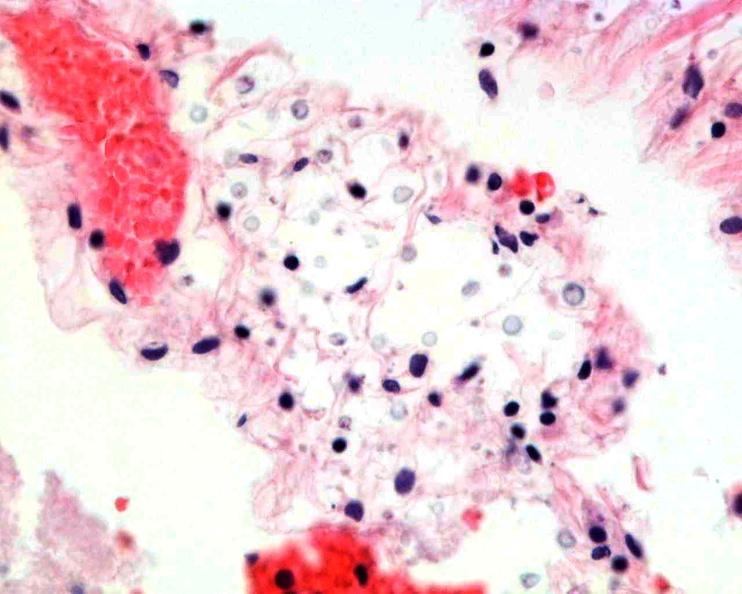where is this?
Answer the question using a single word or phrase. Nervous 